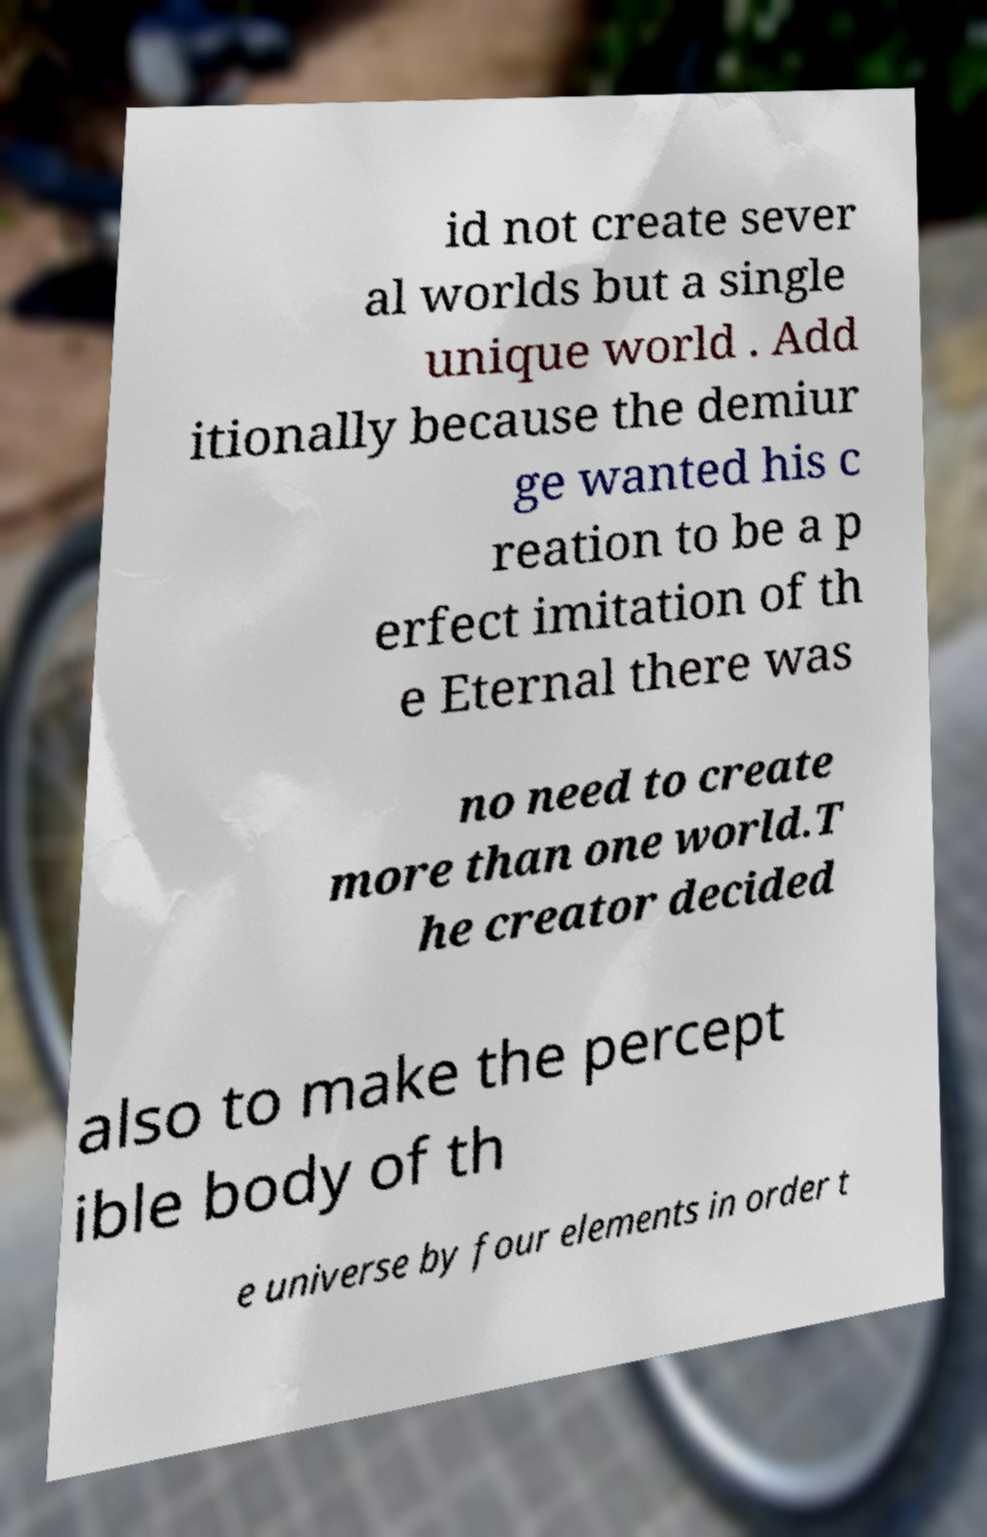Please read and relay the text visible in this image. What does it say? id not create sever al worlds but a single unique world . Add itionally because the demiur ge wanted his c reation to be a p erfect imitation of th e Eternal there was no need to create more than one world.T he creator decided also to make the percept ible body of th e universe by four elements in order t 